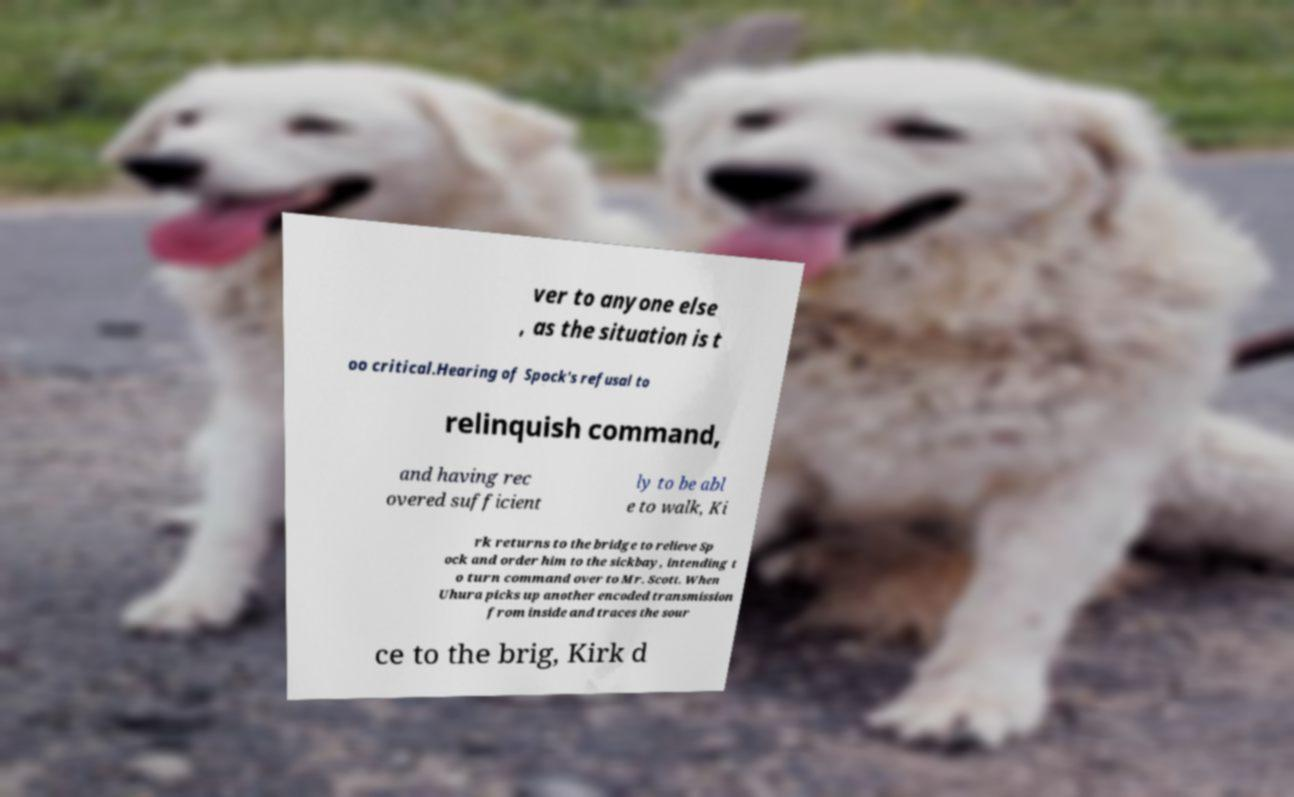There's text embedded in this image that I need extracted. Can you transcribe it verbatim? ver to anyone else , as the situation is t oo critical.Hearing of Spock's refusal to relinquish command, and having rec overed sufficient ly to be abl e to walk, Ki rk returns to the bridge to relieve Sp ock and order him to the sickbay, intending t o turn command over to Mr. Scott. When Uhura picks up another encoded transmission from inside and traces the sour ce to the brig, Kirk d 